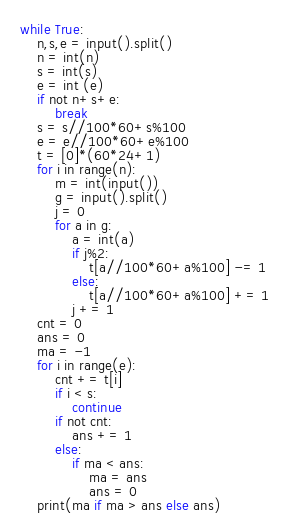<code> <loc_0><loc_0><loc_500><loc_500><_Python_>while True:
    n,s,e = input().split()
    n = int(n)
    s = int(s)
    e = int (e)
    if not n+s+e:
        break
    s = s//100*60+s%100
    e = e//100*60+e%100
    t = [0]*(60*24+1)
    for i in range(n):
        m = int(input())
        g = input().split()
        j = 0
        for a in g:
            a = int(a)
            if j%2:
                t[a//100*60+a%100] -= 1
            else:
                t[a//100*60+a%100] += 1
            j += 1
    cnt = 0
    ans = 0
    ma = -1
    for i in range(e):
        cnt += t[i]
        if i < s:
            continue
        if not cnt:
            ans += 1
        else:
            if ma < ans:
                ma = ans
                ans = 0
    print(ma if ma > ans else ans)</code> 